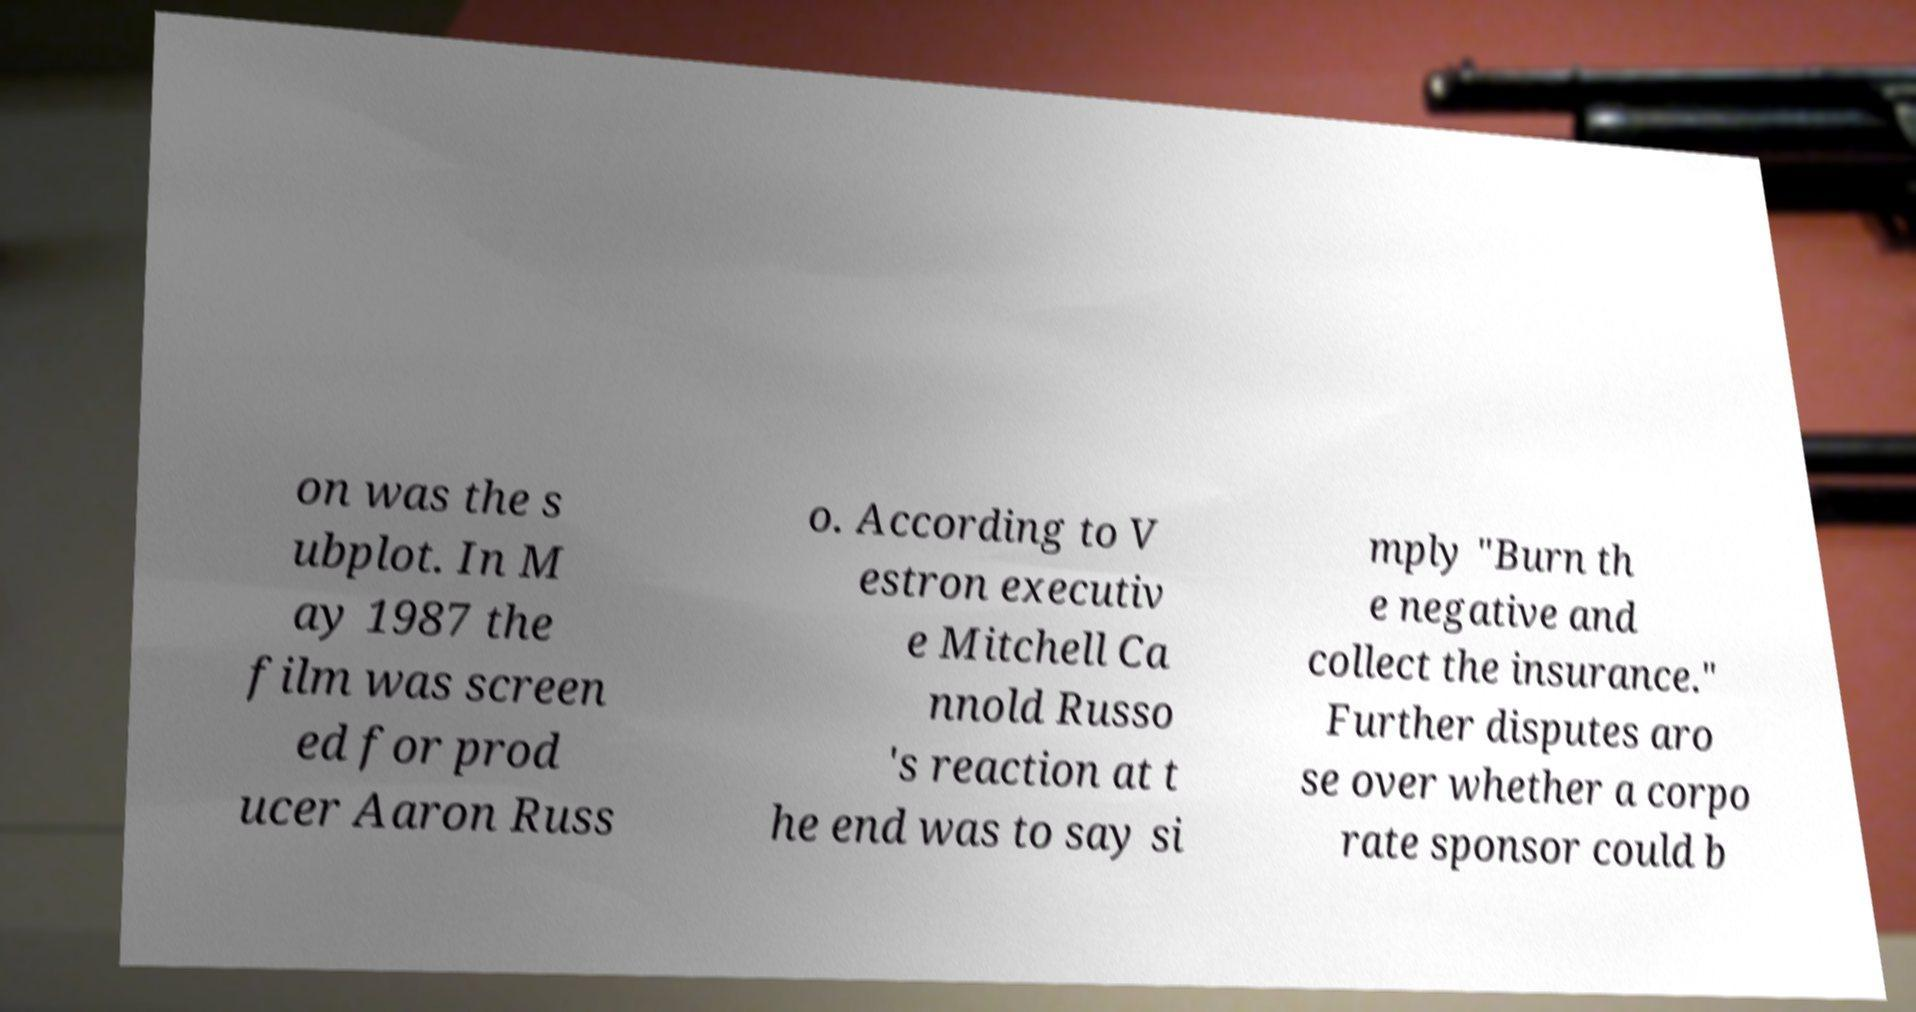Could you assist in decoding the text presented in this image and type it out clearly? on was the s ubplot. In M ay 1987 the film was screen ed for prod ucer Aaron Russ o. According to V estron executiv e Mitchell Ca nnold Russo 's reaction at t he end was to say si mply "Burn th e negative and collect the insurance." Further disputes aro se over whether a corpo rate sponsor could b 